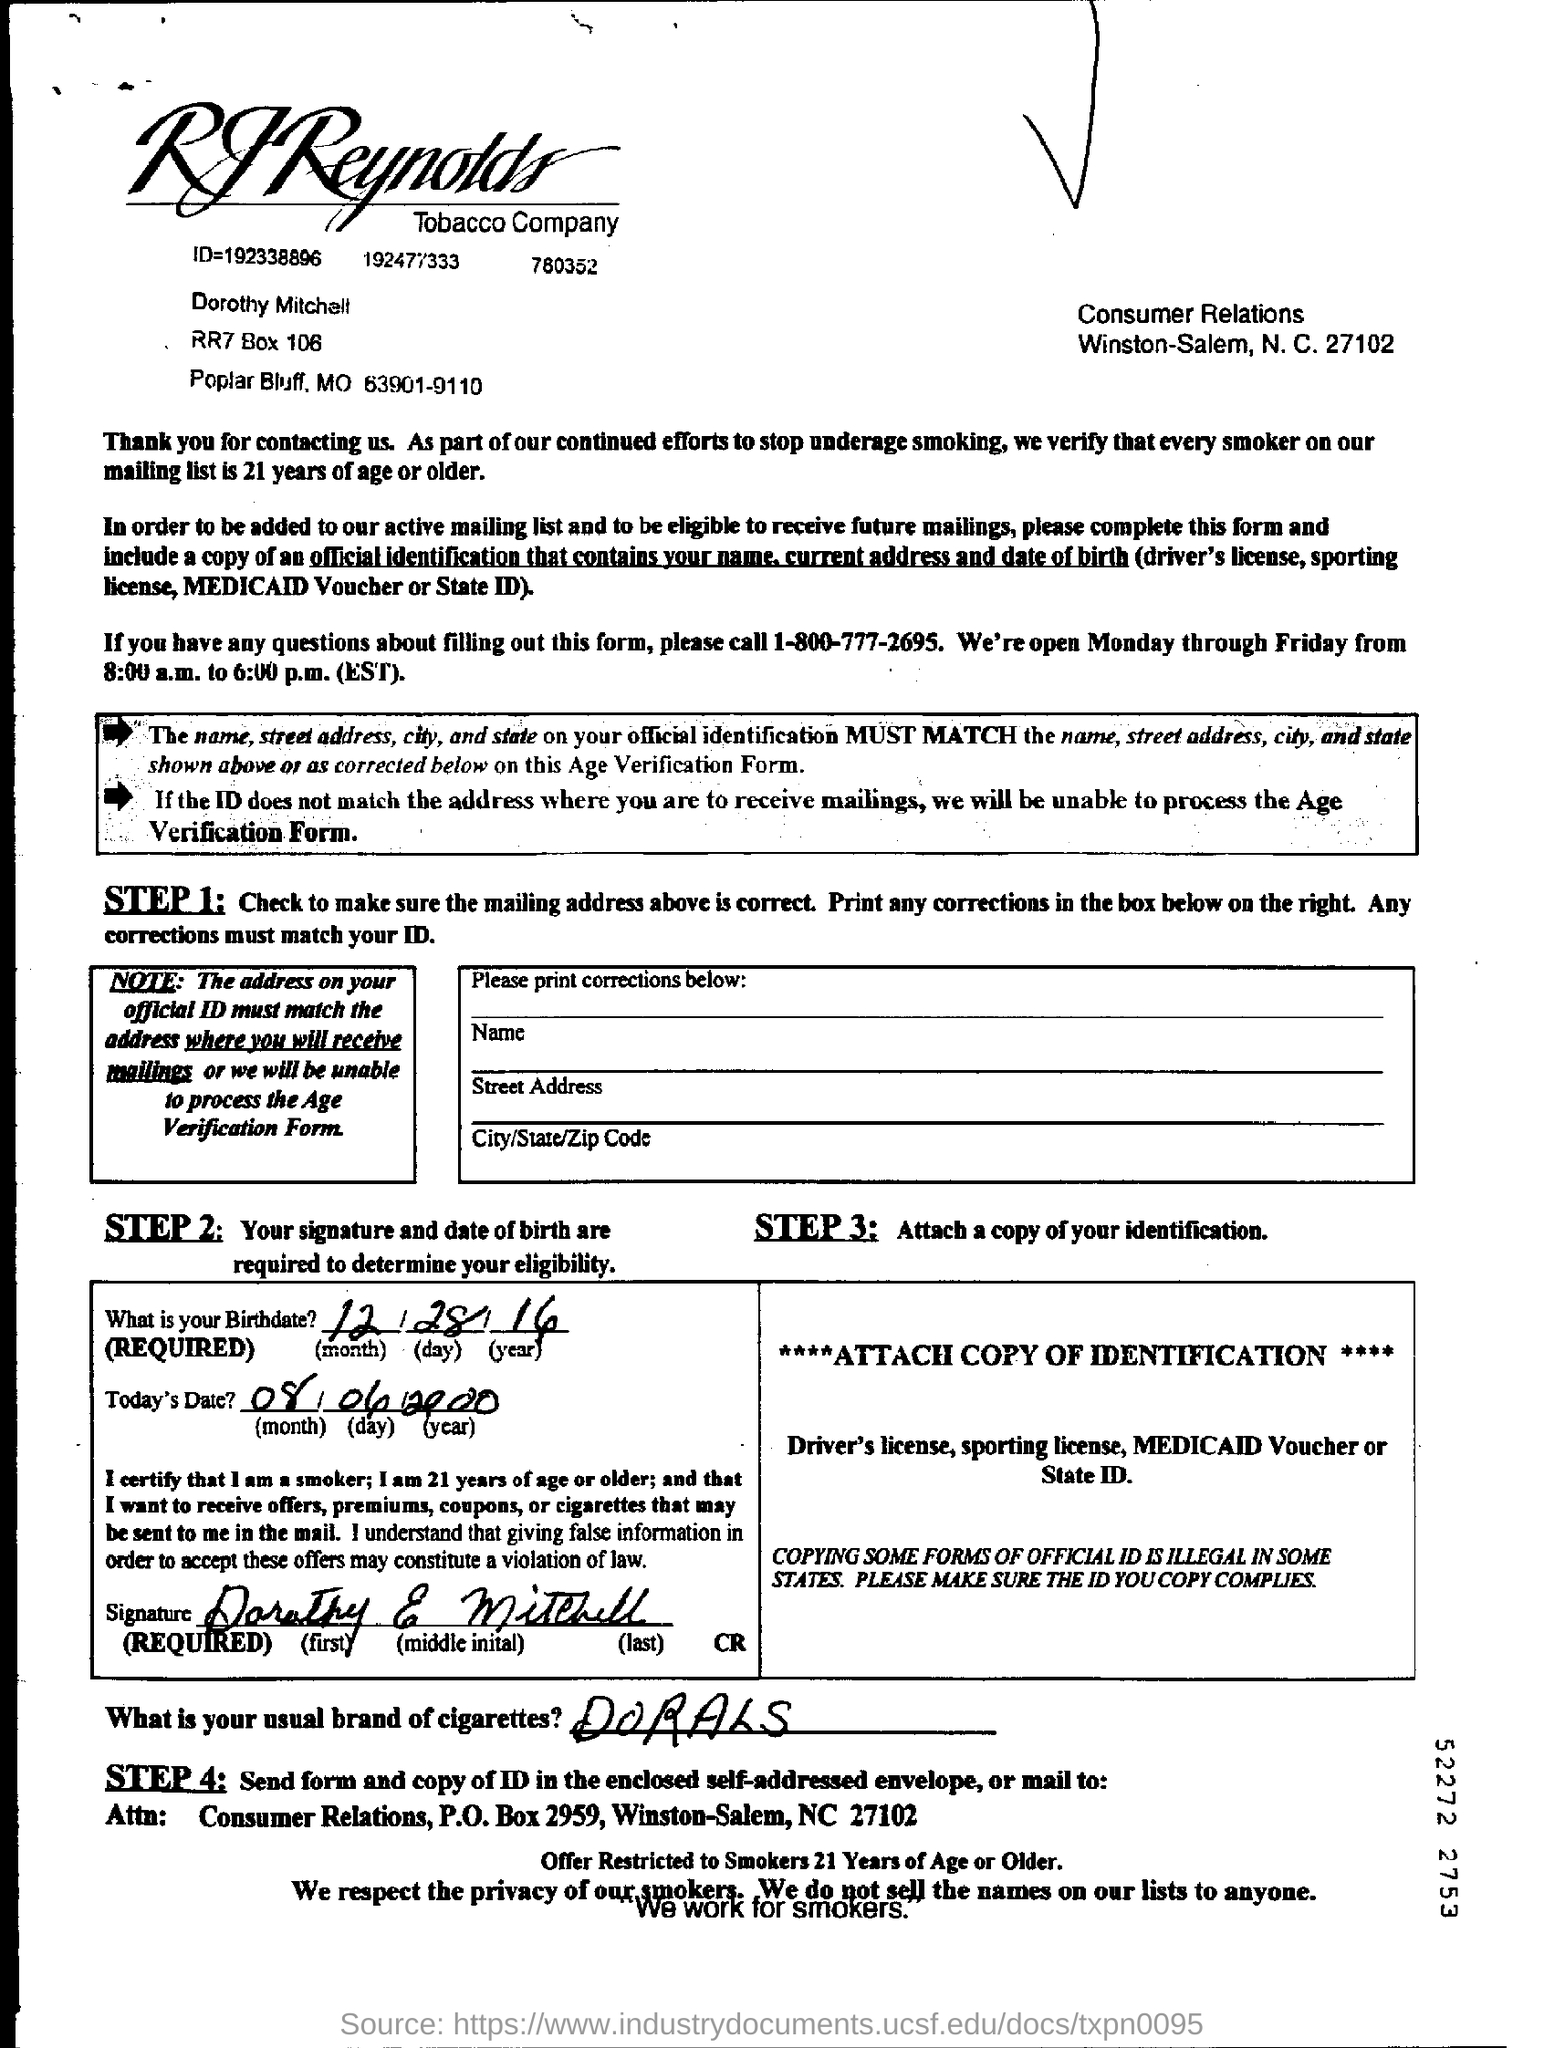Give some essential details in this illustration. It is common for the brand of cigarettes mentioned to be Dorals. The document has been signed by Dorothy E. Mitchell. The speaker is providing a telephone number for inquiries about questions related to filling out the form. The number is 1-800-777-2695. 